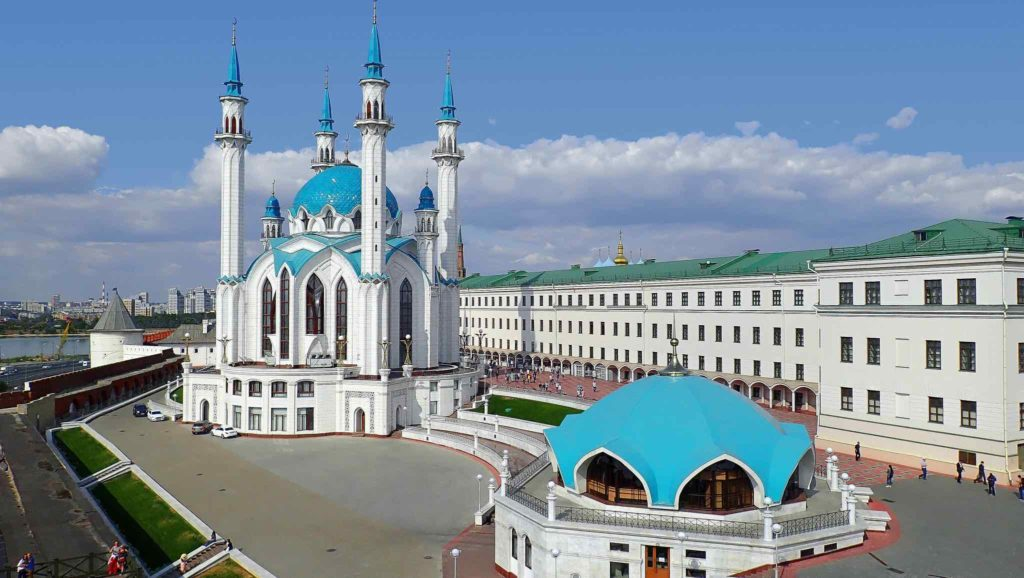How might the scene look in winter? In winter, the Kazan Kremlin transforms into a magical, snow-covered wonderland. The Kul Sharif Mosque, with its blue domes, would be adorned with a blanket of pristine snow, creating a stunning contrast against its white walls. The minarets, capped with snow, would look like ice towers rising into the crisp, winter sky. The Presidential Palace’s green roof would be dotted with fluffy snow, adding to the serene and majestic scene. The red brick walls would be partially coated in white, and the green lawn would be a seamless expanse of snow. Soft light from the winter sun would cast long shadows, enhancing the architectural details and adding a tranquil winter charm to the panoramic view. 